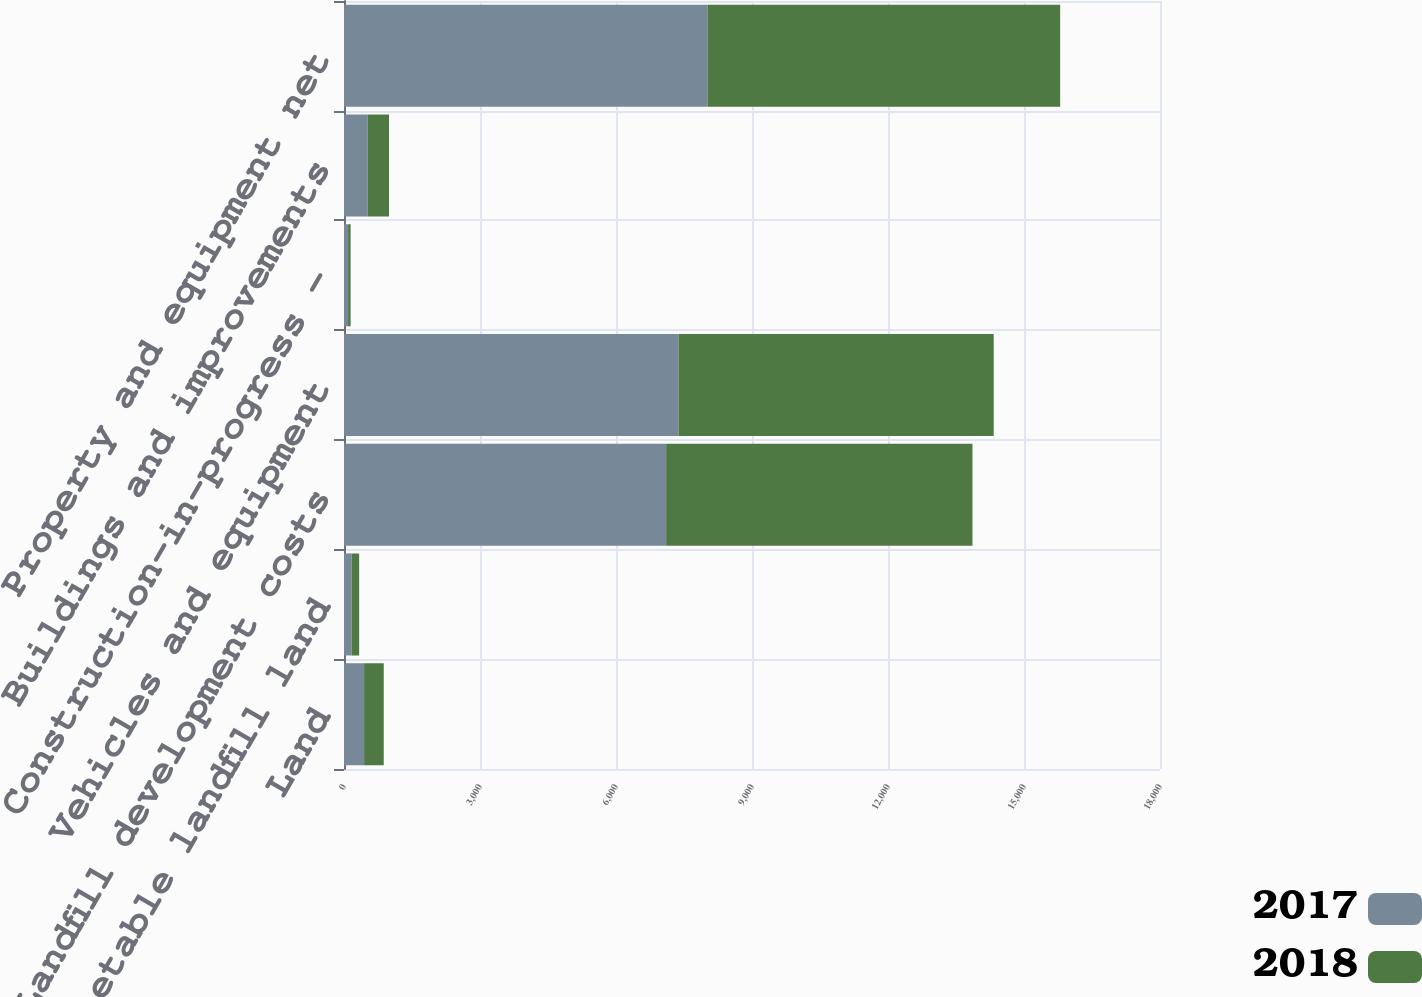Convert chart. <chart><loc_0><loc_0><loc_500><loc_500><stacked_bar_chart><ecel><fcel>Land<fcel>Non-depletable landfill land<fcel>Landfill development costs<fcel>Vehicles and equipment<fcel>Construction-in-progress -<fcel>Buildings and improvements<fcel>Property and equipment net<nl><fcel>2017<fcel>443.6<fcel>167.5<fcel>7106<fcel>7377.3<fcel>89.9<fcel>524.9<fcel>8020.1<nl><fcel>2018<fcel>433.2<fcel>166.9<fcel>6757.3<fcel>6954.3<fcel>55.7<fcel>467.7<fcel>7777.4<nl></chart> 